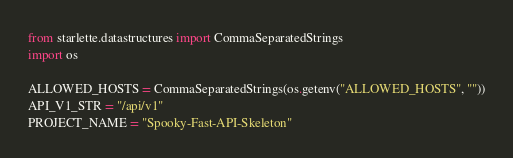Convert code to text. <code><loc_0><loc_0><loc_500><loc_500><_Python_>from starlette.datastructures import CommaSeparatedStrings
import os

ALLOWED_HOSTS = CommaSeparatedStrings(os.getenv("ALLOWED_HOSTS", ""))
API_V1_STR = "/api/v1"
PROJECT_NAME = "Spooky-Fast-API-Skeleton"
</code> 